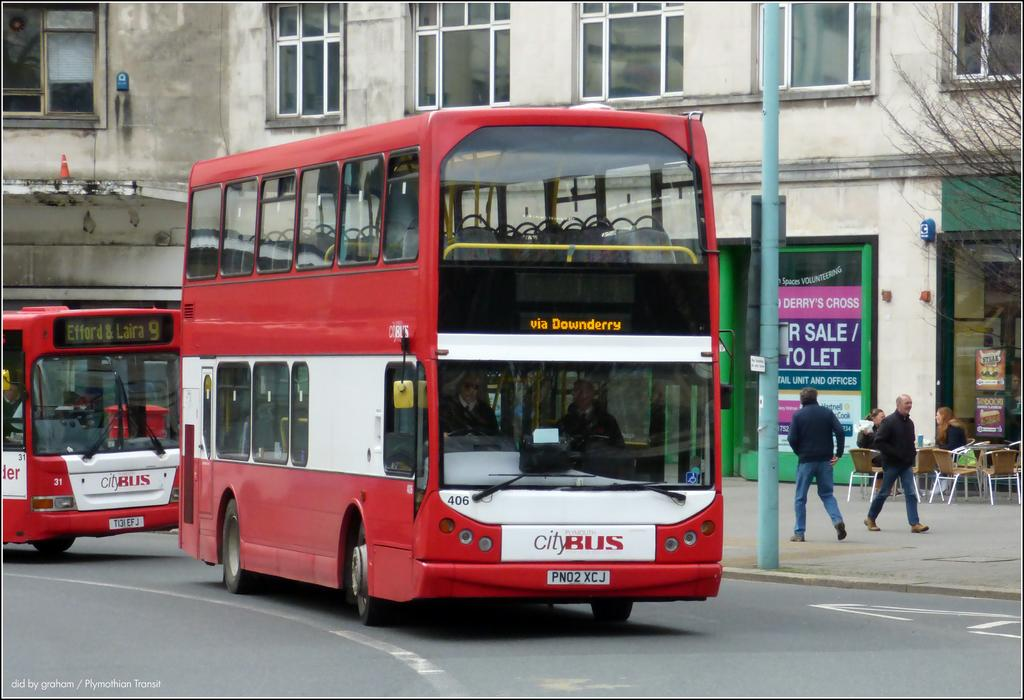<image>
Summarize the visual content of the image. City Bus via Downderry is displayed on the front of this public bus. 